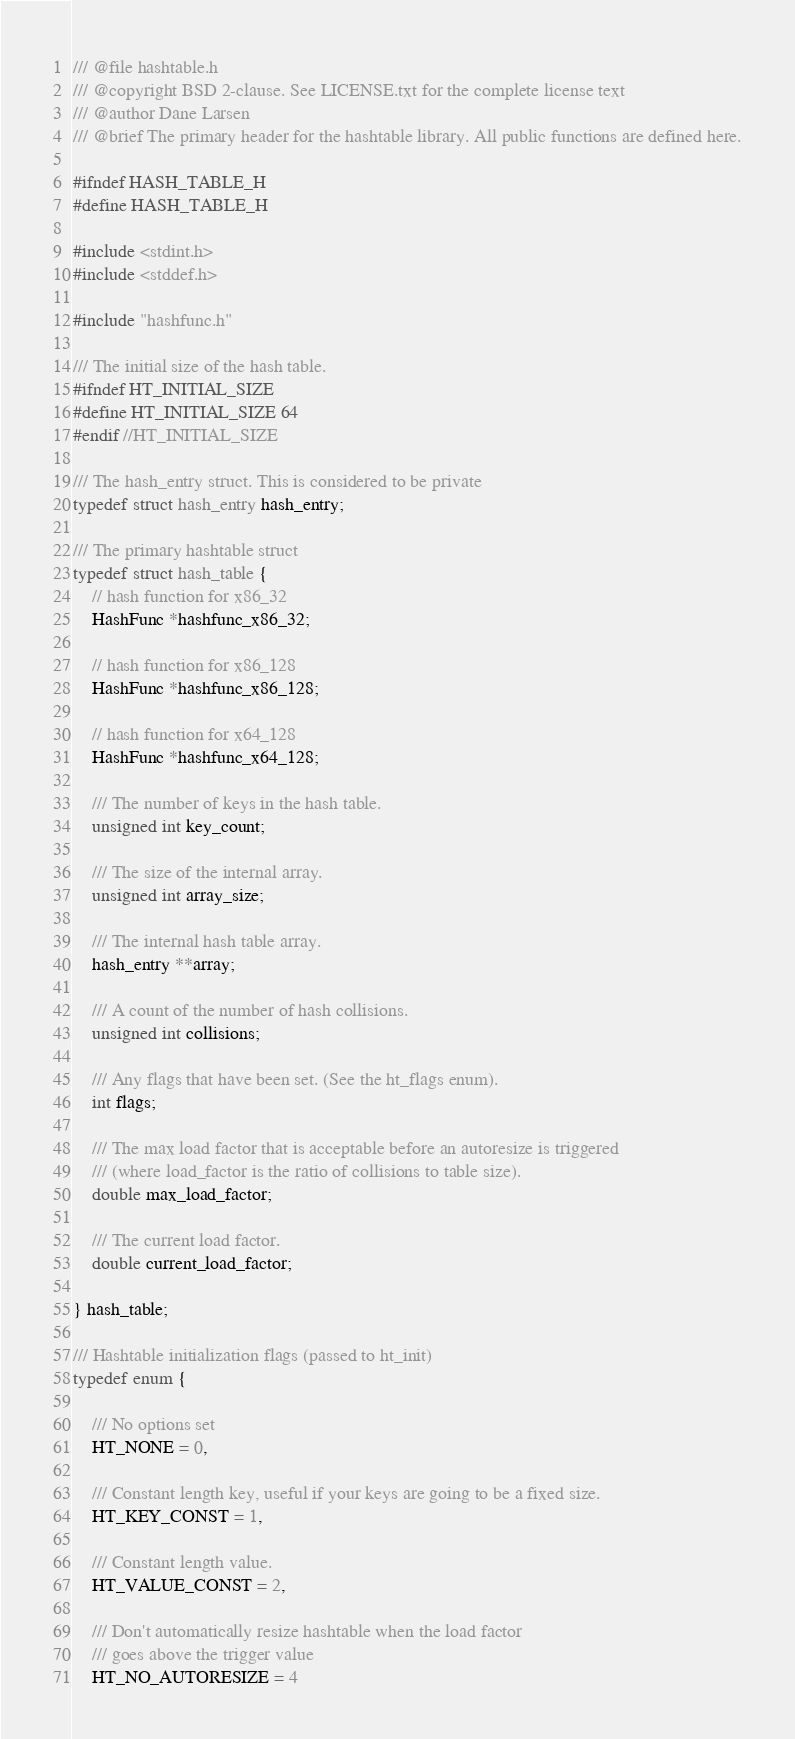Convert code to text. <code><loc_0><loc_0><loc_500><loc_500><_C_>/// @file hashtable.h
/// @copyright BSD 2-clause. See LICENSE.txt for the complete license text
/// @author Dane Larsen
/// @brief The primary header for the hashtable library. All public functions are defined here.

#ifndef HASH_TABLE_H
#define HASH_TABLE_H

#include <stdint.h>
#include <stddef.h>

#include "hashfunc.h"

/// The initial size of the hash table.
#ifndef HT_INITIAL_SIZE
#define HT_INITIAL_SIZE 64
#endif //HT_INITIAL_SIZE

/// The hash_entry struct. This is considered to be private
typedef struct hash_entry hash_entry;

/// The primary hashtable struct
typedef struct hash_table {
    // hash function for x86_32
    HashFunc *hashfunc_x86_32;

    // hash function for x86_128
    HashFunc *hashfunc_x86_128;

    // hash function for x64_128
    HashFunc *hashfunc_x64_128;

    /// The number of keys in the hash table.
    unsigned int key_count;

    /// The size of the internal array.
    unsigned int array_size;

    /// The internal hash table array.
    hash_entry **array;

    /// A count of the number of hash collisions.
    unsigned int collisions;

    /// Any flags that have been set. (See the ht_flags enum).
    int flags;

    /// The max load factor that is acceptable before an autoresize is triggered
    /// (where load_factor is the ratio of collisions to table size).
    double max_load_factor;

    /// The current load factor.
    double current_load_factor;

} hash_table;

/// Hashtable initialization flags (passed to ht_init)
typedef enum {

    /// No options set
    HT_NONE = 0,

    /// Constant length key, useful if your keys are going to be a fixed size.
    HT_KEY_CONST = 1,

    /// Constant length value.
    HT_VALUE_CONST = 2,

    /// Don't automatically resize hashtable when the load factor
    /// goes above the trigger value
    HT_NO_AUTORESIZE = 4
</code> 